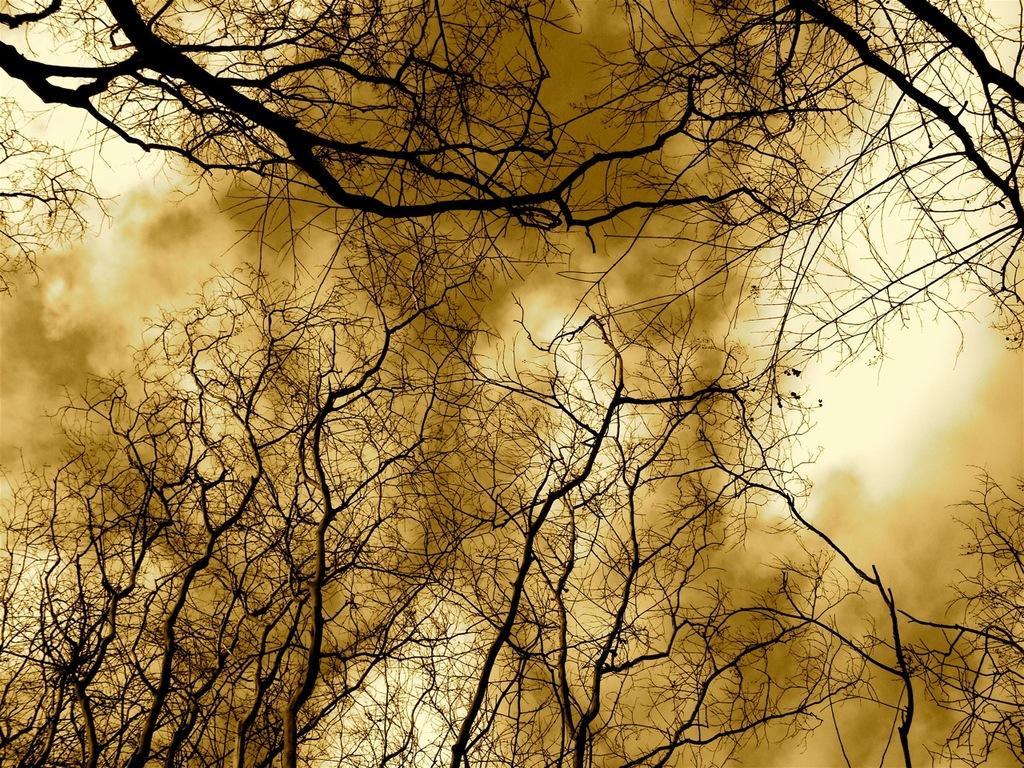Could you give a brief overview of what you see in this image? In this image I can see few trees which are black in color and the brown colored smoke. In the background I can see the sky. 